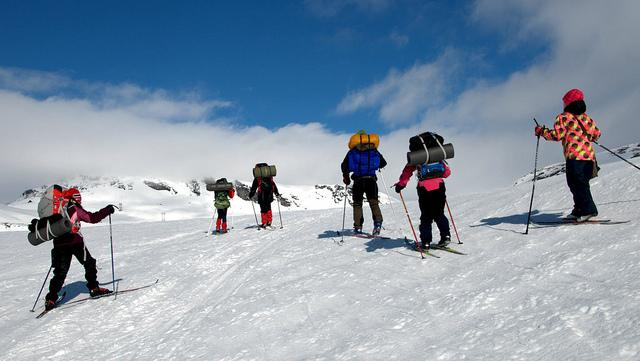Where are they going?

Choices:
A) rest stop
B) home
C) lunch
D) uphill uphill 